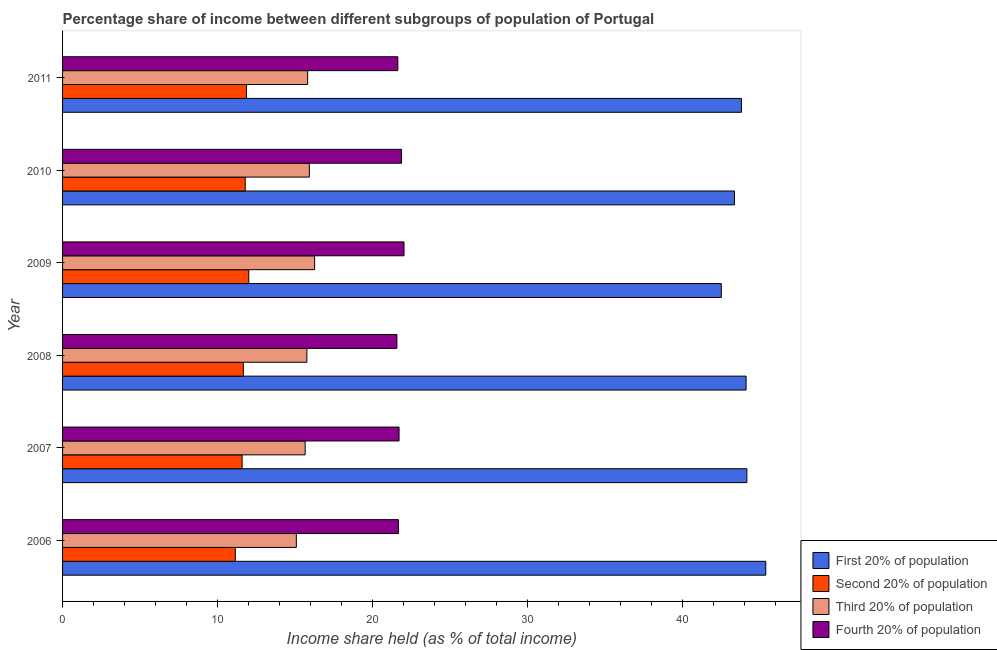How many different coloured bars are there?
Ensure brevity in your answer.  4. How many groups of bars are there?
Your answer should be very brief. 6. Are the number of bars on each tick of the Y-axis equal?
Provide a succinct answer. Yes. In how many cases, is the number of bars for a given year not equal to the number of legend labels?
Give a very brief answer. 0. What is the share of the income held by second 20% of the population in 2011?
Make the answer very short. 11.87. Across all years, what is the maximum share of the income held by second 20% of the population?
Your answer should be very brief. 12.02. Across all years, what is the minimum share of the income held by first 20% of the population?
Offer a terse response. 42.52. In which year was the share of the income held by second 20% of the population minimum?
Provide a succinct answer. 2006. What is the total share of the income held by first 20% of the population in the graph?
Your response must be concise. 263.39. What is the difference between the share of the income held by second 20% of the population in 2009 and that in 2010?
Your response must be concise. 0.23. What is the difference between the share of the income held by second 20% of the population in 2009 and the share of the income held by first 20% of the population in 2007?
Offer a terse response. -32.15. What is the average share of the income held by first 20% of the population per year?
Your answer should be compact. 43.9. In the year 2006, what is the difference between the share of the income held by fourth 20% of the population and share of the income held by third 20% of the population?
Provide a succinct answer. 6.59. In how many years, is the share of the income held by first 20% of the population greater than 2 %?
Offer a terse response. 6. What is the ratio of the share of the income held by first 20% of the population in 2007 to that in 2009?
Offer a terse response. 1.04. Is the share of the income held by second 20% of the population in 2009 less than that in 2011?
Your answer should be compact. No. What is the difference between the highest and the second highest share of the income held by second 20% of the population?
Ensure brevity in your answer.  0.15. What is the difference between the highest and the lowest share of the income held by third 20% of the population?
Give a very brief answer. 1.18. In how many years, is the share of the income held by first 20% of the population greater than the average share of the income held by first 20% of the population taken over all years?
Your answer should be compact. 3. Is the sum of the share of the income held by first 20% of the population in 2006 and 2010 greater than the maximum share of the income held by second 20% of the population across all years?
Offer a terse response. Yes. Is it the case that in every year, the sum of the share of the income held by third 20% of the population and share of the income held by fourth 20% of the population is greater than the sum of share of the income held by first 20% of the population and share of the income held by second 20% of the population?
Ensure brevity in your answer.  No. What does the 2nd bar from the top in 2006 represents?
Provide a short and direct response. Third 20% of population. What does the 1st bar from the bottom in 2008 represents?
Provide a short and direct response. First 20% of population. How many bars are there?
Your answer should be compact. 24. How many years are there in the graph?
Provide a short and direct response. 6. Does the graph contain any zero values?
Provide a succinct answer. No. Where does the legend appear in the graph?
Offer a terse response. Bottom right. How many legend labels are there?
Ensure brevity in your answer.  4. How are the legend labels stacked?
Offer a terse response. Vertical. What is the title of the graph?
Ensure brevity in your answer.  Percentage share of income between different subgroups of population of Portugal. What is the label or title of the X-axis?
Ensure brevity in your answer.  Income share held (as % of total income). What is the Income share held (as % of total income) in First 20% of population in 2006?
Your answer should be compact. 45.39. What is the Income share held (as % of total income) in Second 20% of population in 2006?
Keep it short and to the point. 11.15. What is the Income share held (as % of total income) in Third 20% of population in 2006?
Offer a terse response. 15.09. What is the Income share held (as % of total income) in Fourth 20% of population in 2006?
Provide a succinct answer. 21.68. What is the Income share held (as % of total income) in First 20% of population in 2007?
Ensure brevity in your answer.  44.17. What is the Income share held (as % of total income) of Second 20% of population in 2007?
Provide a succinct answer. 11.59. What is the Income share held (as % of total income) in Third 20% of population in 2007?
Provide a short and direct response. 15.66. What is the Income share held (as % of total income) in Fourth 20% of population in 2007?
Your answer should be compact. 21.72. What is the Income share held (as % of total income) in First 20% of population in 2008?
Make the answer very short. 44.12. What is the Income share held (as % of total income) in Second 20% of population in 2008?
Offer a very short reply. 11.67. What is the Income share held (as % of total income) of Third 20% of population in 2008?
Offer a terse response. 15.77. What is the Income share held (as % of total income) of Fourth 20% of population in 2008?
Your response must be concise. 21.58. What is the Income share held (as % of total income) in First 20% of population in 2009?
Your answer should be compact. 42.52. What is the Income share held (as % of total income) in Second 20% of population in 2009?
Offer a terse response. 12.02. What is the Income share held (as % of total income) in Third 20% of population in 2009?
Keep it short and to the point. 16.27. What is the Income share held (as % of total income) of Fourth 20% of population in 2009?
Keep it short and to the point. 22.04. What is the Income share held (as % of total income) in First 20% of population in 2010?
Offer a very short reply. 43.37. What is the Income share held (as % of total income) of Second 20% of population in 2010?
Provide a succinct answer. 11.79. What is the Income share held (as % of total income) of Third 20% of population in 2010?
Your response must be concise. 15.93. What is the Income share held (as % of total income) of Fourth 20% of population in 2010?
Give a very brief answer. 21.88. What is the Income share held (as % of total income) of First 20% of population in 2011?
Provide a short and direct response. 43.82. What is the Income share held (as % of total income) of Second 20% of population in 2011?
Make the answer very short. 11.87. What is the Income share held (as % of total income) in Third 20% of population in 2011?
Offer a terse response. 15.82. What is the Income share held (as % of total income) of Fourth 20% of population in 2011?
Your response must be concise. 21.64. Across all years, what is the maximum Income share held (as % of total income) of First 20% of population?
Offer a very short reply. 45.39. Across all years, what is the maximum Income share held (as % of total income) in Second 20% of population?
Offer a terse response. 12.02. Across all years, what is the maximum Income share held (as % of total income) of Third 20% of population?
Offer a terse response. 16.27. Across all years, what is the maximum Income share held (as % of total income) of Fourth 20% of population?
Ensure brevity in your answer.  22.04. Across all years, what is the minimum Income share held (as % of total income) in First 20% of population?
Keep it short and to the point. 42.52. Across all years, what is the minimum Income share held (as % of total income) in Second 20% of population?
Keep it short and to the point. 11.15. Across all years, what is the minimum Income share held (as % of total income) of Third 20% of population?
Offer a very short reply. 15.09. Across all years, what is the minimum Income share held (as % of total income) of Fourth 20% of population?
Ensure brevity in your answer.  21.58. What is the total Income share held (as % of total income) in First 20% of population in the graph?
Your answer should be compact. 263.39. What is the total Income share held (as % of total income) of Second 20% of population in the graph?
Keep it short and to the point. 70.09. What is the total Income share held (as % of total income) in Third 20% of population in the graph?
Offer a terse response. 94.54. What is the total Income share held (as % of total income) in Fourth 20% of population in the graph?
Your response must be concise. 130.54. What is the difference between the Income share held (as % of total income) in First 20% of population in 2006 and that in 2007?
Your response must be concise. 1.22. What is the difference between the Income share held (as % of total income) in Second 20% of population in 2006 and that in 2007?
Offer a very short reply. -0.44. What is the difference between the Income share held (as % of total income) of Third 20% of population in 2006 and that in 2007?
Keep it short and to the point. -0.57. What is the difference between the Income share held (as % of total income) of Fourth 20% of population in 2006 and that in 2007?
Provide a short and direct response. -0.04. What is the difference between the Income share held (as % of total income) of First 20% of population in 2006 and that in 2008?
Your response must be concise. 1.27. What is the difference between the Income share held (as % of total income) of Second 20% of population in 2006 and that in 2008?
Make the answer very short. -0.52. What is the difference between the Income share held (as % of total income) in Third 20% of population in 2006 and that in 2008?
Provide a short and direct response. -0.68. What is the difference between the Income share held (as % of total income) in Fourth 20% of population in 2006 and that in 2008?
Give a very brief answer. 0.1. What is the difference between the Income share held (as % of total income) of First 20% of population in 2006 and that in 2009?
Offer a terse response. 2.87. What is the difference between the Income share held (as % of total income) in Second 20% of population in 2006 and that in 2009?
Provide a short and direct response. -0.87. What is the difference between the Income share held (as % of total income) of Third 20% of population in 2006 and that in 2009?
Your answer should be compact. -1.18. What is the difference between the Income share held (as % of total income) of Fourth 20% of population in 2006 and that in 2009?
Your response must be concise. -0.36. What is the difference between the Income share held (as % of total income) of First 20% of population in 2006 and that in 2010?
Provide a succinct answer. 2.02. What is the difference between the Income share held (as % of total income) of Second 20% of population in 2006 and that in 2010?
Your answer should be very brief. -0.64. What is the difference between the Income share held (as % of total income) in Third 20% of population in 2006 and that in 2010?
Provide a short and direct response. -0.84. What is the difference between the Income share held (as % of total income) in First 20% of population in 2006 and that in 2011?
Make the answer very short. 1.57. What is the difference between the Income share held (as % of total income) in Second 20% of population in 2006 and that in 2011?
Your answer should be compact. -0.72. What is the difference between the Income share held (as % of total income) in Third 20% of population in 2006 and that in 2011?
Your answer should be very brief. -0.73. What is the difference between the Income share held (as % of total income) of Fourth 20% of population in 2006 and that in 2011?
Keep it short and to the point. 0.04. What is the difference between the Income share held (as % of total income) of First 20% of population in 2007 and that in 2008?
Ensure brevity in your answer.  0.05. What is the difference between the Income share held (as % of total income) of Second 20% of population in 2007 and that in 2008?
Provide a short and direct response. -0.08. What is the difference between the Income share held (as % of total income) in Third 20% of population in 2007 and that in 2008?
Your answer should be very brief. -0.11. What is the difference between the Income share held (as % of total income) of Fourth 20% of population in 2007 and that in 2008?
Provide a short and direct response. 0.14. What is the difference between the Income share held (as % of total income) of First 20% of population in 2007 and that in 2009?
Your answer should be compact. 1.65. What is the difference between the Income share held (as % of total income) of Second 20% of population in 2007 and that in 2009?
Give a very brief answer. -0.43. What is the difference between the Income share held (as % of total income) in Third 20% of population in 2007 and that in 2009?
Make the answer very short. -0.61. What is the difference between the Income share held (as % of total income) in Fourth 20% of population in 2007 and that in 2009?
Ensure brevity in your answer.  -0.32. What is the difference between the Income share held (as % of total income) in First 20% of population in 2007 and that in 2010?
Your answer should be very brief. 0.8. What is the difference between the Income share held (as % of total income) of Third 20% of population in 2007 and that in 2010?
Offer a terse response. -0.27. What is the difference between the Income share held (as % of total income) in Fourth 20% of population in 2007 and that in 2010?
Ensure brevity in your answer.  -0.16. What is the difference between the Income share held (as % of total income) in Second 20% of population in 2007 and that in 2011?
Make the answer very short. -0.28. What is the difference between the Income share held (as % of total income) in Third 20% of population in 2007 and that in 2011?
Keep it short and to the point. -0.16. What is the difference between the Income share held (as % of total income) in First 20% of population in 2008 and that in 2009?
Your answer should be compact. 1.6. What is the difference between the Income share held (as % of total income) of Second 20% of population in 2008 and that in 2009?
Give a very brief answer. -0.35. What is the difference between the Income share held (as % of total income) of Fourth 20% of population in 2008 and that in 2009?
Make the answer very short. -0.46. What is the difference between the Income share held (as % of total income) of Second 20% of population in 2008 and that in 2010?
Your answer should be compact. -0.12. What is the difference between the Income share held (as % of total income) of Third 20% of population in 2008 and that in 2010?
Provide a short and direct response. -0.16. What is the difference between the Income share held (as % of total income) in Fourth 20% of population in 2008 and that in 2010?
Your answer should be compact. -0.3. What is the difference between the Income share held (as % of total income) in Second 20% of population in 2008 and that in 2011?
Offer a very short reply. -0.2. What is the difference between the Income share held (as % of total income) of Third 20% of population in 2008 and that in 2011?
Your answer should be compact. -0.05. What is the difference between the Income share held (as % of total income) in Fourth 20% of population in 2008 and that in 2011?
Your answer should be very brief. -0.06. What is the difference between the Income share held (as % of total income) in First 20% of population in 2009 and that in 2010?
Offer a very short reply. -0.85. What is the difference between the Income share held (as % of total income) in Second 20% of population in 2009 and that in 2010?
Give a very brief answer. 0.23. What is the difference between the Income share held (as % of total income) of Third 20% of population in 2009 and that in 2010?
Keep it short and to the point. 0.34. What is the difference between the Income share held (as % of total income) in Fourth 20% of population in 2009 and that in 2010?
Provide a short and direct response. 0.16. What is the difference between the Income share held (as % of total income) of Third 20% of population in 2009 and that in 2011?
Your answer should be very brief. 0.45. What is the difference between the Income share held (as % of total income) of Fourth 20% of population in 2009 and that in 2011?
Your response must be concise. 0.4. What is the difference between the Income share held (as % of total income) in First 20% of population in 2010 and that in 2011?
Your answer should be very brief. -0.45. What is the difference between the Income share held (as % of total income) in Second 20% of population in 2010 and that in 2011?
Offer a terse response. -0.08. What is the difference between the Income share held (as % of total income) in Third 20% of population in 2010 and that in 2011?
Offer a very short reply. 0.11. What is the difference between the Income share held (as % of total income) of Fourth 20% of population in 2010 and that in 2011?
Your answer should be very brief. 0.24. What is the difference between the Income share held (as % of total income) of First 20% of population in 2006 and the Income share held (as % of total income) of Second 20% of population in 2007?
Make the answer very short. 33.8. What is the difference between the Income share held (as % of total income) of First 20% of population in 2006 and the Income share held (as % of total income) of Third 20% of population in 2007?
Give a very brief answer. 29.73. What is the difference between the Income share held (as % of total income) in First 20% of population in 2006 and the Income share held (as % of total income) in Fourth 20% of population in 2007?
Keep it short and to the point. 23.67. What is the difference between the Income share held (as % of total income) in Second 20% of population in 2006 and the Income share held (as % of total income) in Third 20% of population in 2007?
Keep it short and to the point. -4.51. What is the difference between the Income share held (as % of total income) in Second 20% of population in 2006 and the Income share held (as % of total income) in Fourth 20% of population in 2007?
Provide a succinct answer. -10.57. What is the difference between the Income share held (as % of total income) of Third 20% of population in 2006 and the Income share held (as % of total income) of Fourth 20% of population in 2007?
Your response must be concise. -6.63. What is the difference between the Income share held (as % of total income) of First 20% of population in 2006 and the Income share held (as % of total income) of Second 20% of population in 2008?
Provide a short and direct response. 33.72. What is the difference between the Income share held (as % of total income) of First 20% of population in 2006 and the Income share held (as % of total income) of Third 20% of population in 2008?
Your answer should be very brief. 29.62. What is the difference between the Income share held (as % of total income) of First 20% of population in 2006 and the Income share held (as % of total income) of Fourth 20% of population in 2008?
Keep it short and to the point. 23.81. What is the difference between the Income share held (as % of total income) of Second 20% of population in 2006 and the Income share held (as % of total income) of Third 20% of population in 2008?
Provide a succinct answer. -4.62. What is the difference between the Income share held (as % of total income) of Second 20% of population in 2006 and the Income share held (as % of total income) of Fourth 20% of population in 2008?
Provide a short and direct response. -10.43. What is the difference between the Income share held (as % of total income) in Third 20% of population in 2006 and the Income share held (as % of total income) in Fourth 20% of population in 2008?
Ensure brevity in your answer.  -6.49. What is the difference between the Income share held (as % of total income) of First 20% of population in 2006 and the Income share held (as % of total income) of Second 20% of population in 2009?
Ensure brevity in your answer.  33.37. What is the difference between the Income share held (as % of total income) in First 20% of population in 2006 and the Income share held (as % of total income) in Third 20% of population in 2009?
Ensure brevity in your answer.  29.12. What is the difference between the Income share held (as % of total income) in First 20% of population in 2006 and the Income share held (as % of total income) in Fourth 20% of population in 2009?
Offer a very short reply. 23.35. What is the difference between the Income share held (as % of total income) in Second 20% of population in 2006 and the Income share held (as % of total income) in Third 20% of population in 2009?
Give a very brief answer. -5.12. What is the difference between the Income share held (as % of total income) of Second 20% of population in 2006 and the Income share held (as % of total income) of Fourth 20% of population in 2009?
Offer a very short reply. -10.89. What is the difference between the Income share held (as % of total income) of Third 20% of population in 2006 and the Income share held (as % of total income) of Fourth 20% of population in 2009?
Provide a succinct answer. -6.95. What is the difference between the Income share held (as % of total income) in First 20% of population in 2006 and the Income share held (as % of total income) in Second 20% of population in 2010?
Make the answer very short. 33.6. What is the difference between the Income share held (as % of total income) in First 20% of population in 2006 and the Income share held (as % of total income) in Third 20% of population in 2010?
Make the answer very short. 29.46. What is the difference between the Income share held (as % of total income) of First 20% of population in 2006 and the Income share held (as % of total income) of Fourth 20% of population in 2010?
Give a very brief answer. 23.51. What is the difference between the Income share held (as % of total income) of Second 20% of population in 2006 and the Income share held (as % of total income) of Third 20% of population in 2010?
Provide a short and direct response. -4.78. What is the difference between the Income share held (as % of total income) in Second 20% of population in 2006 and the Income share held (as % of total income) in Fourth 20% of population in 2010?
Offer a very short reply. -10.73. What is the difference between the Income share held (as % of total income) in Third 20% of population in 2006 and the Income share held (as % of total income) in Fourth 20% of population in 2010?
Your answer should be compact. -6.79. What is the difference between the Income share held (as % of total income) in First 20% of population in 2006 and the Income share held (as % of total income) in Second 20% of population in 2011?
Give a very brief answer. 33.52. What is the difference between the Income share held (as % of total income) of First 20% of population in 2006 and the Income share held (as % of total income) of Third 20% of population in 2011?
Provide a succinct answer. 29.57. What is the difference between the Income share held (as % of total income) in First 20% of population in 2006 and the Income share held (as % of total income) in Fourth 20% of population in 2011?
Provide a succinct answer. 23.75. What is the difference between the Income share held (as % of total income) in Second 20% of population in 2006 and the Income share held (as % of total income) in Third 20% of population in 2011?
Your response must be concise. -4.67. What is the difference between the Income share held (as % of total income) in Second 20% of population in 2006 and the Income share held (as % of total income) in Fourth 20% of population in 2011?
Give a very brief answer. -10.49. What is the difference between the Income share held (as % of total income) of Third 20% of population in 2006 and the Income share held (as % of total income) of Fourth 20% of population in 2011?
Give a very brief answer. -6.55. What is the difference between the Income share held (as % of total income) in First 20% of population in 2007 and the Income share held (as % of total income) in Second 20% of population in 2008?
Ensure brevity in your answer.  32.5. What is the difference between the Income share held (as % of total income) in First 20% of population in 2007 and the Income share held (as % of total income) in Third 20% of population in 2008?
Offer a very short reply. 28.4. What is the difference between the Income share held (as % of total income) of First 20% of population in 2007 and the Income share held (as % of total income) of Fourth 20% of population in 2008?
Your answer should be compact. 22.59. What is the difference between the Income share held (as % of total income) of Second 20% of population in 2007 and the Income share held (as % of total income) of Third 20% of population in 2008?
Ensure brevity in your answer.  -4.18. What is the difference between the Income share held (as % of total income) in Second 20% of population in 2007 and the Income share held (as % of total income) in Fourth 20% of population in 2008?
Make the answer very short. -9.99. What is the difference between the Income share held (as % of total income) of Third 20% of population in 2007 and the Income share held (as % of total income) of Fourth 20% of population in 2008?
Your response must be concise. -5.92. What is the difference between the Income share held (as % of total income) in First 20% of population in 2007 and the Income share held (as % of total income) in Second 20% of population in 2009?
Ensure brevity in your answer.  32.15. What is the difference between the Income share held (as % of total income) in First 20% of population in 2007 and the Income share held (as % of total income) in Third 20% of population in 2009?
Offer a terse response. 27.9. What is the difference between the Income share held (as % of total income) of First 20% of population in 2007 and the Income share held (as % of total income) of Fourth 20% of population in 2009?
Give a very brief answer. 22.13. What is the difference between the Income share held (as % of total income) of Second 20% of population in 2007 and the Income share held (as % of total income) of Third 20% of population in 2009?
Offer a very short reply. -4.68. What is the difference between the Income share held (as % of total income) of Second 20% of population in 2007 and the Income share held (as % of total income) of Fourth 20% of population in 2009?
Offer a terse response. -10.45. What is the difference between the Income share held (as % of total income) of Third 20% of population in 2007 and the Income share held (as % of total income) of Fourth 20% of population in 2009?
Offer a very short reply. -6.38. What is the difference between the Income share held (as % of total income) in First 20% of population in 2007 and the Income share held (as % of total income) in Second 20% of population in 2010?
Your answer should be very brief. 32.38. What is the difference between the Income share held (as % of total income) of First 20% of population in 2007 and the Income share held (as % of total income) of Third 20% of population in 2010?
Your answer should be compact. 28.24. What is the difference between the Income share held (as % of total income) in First 20% of population in 2007 and the Income share held (as % of total income) in Fourth 20% of population in 2010?
Provide a short and direct response. 22.29. What is the difference between the Income share held (as % of total income) in Second 20% of population in 2007 and the Income share held (as % of total income) in Third 20% of population in 2010?
Offer a terse response. -4.34. What is the difference between the Income share held (as % of total income) of Second 20% of population in 2007 and the Income share held (as % of total income) of Fourth 20% of population in 2010?
Offer a terse response. -10.29. What is the difference between the Income share held (as % of total income) in Third 20% of population in 2007 and the Income share held (as % of total income) in Fourth 20% of population in 2010?
Give a very brief answer. -6.22. What is the difference between the Income share held (as % of total income) of First 20% of population in 2007 and the Income share held (as % of total income) of Second 20% of population in 2011?
Your answer should be very brief. 32.3. What is the difference between the Income share held (as % of total income) in First 20% of population in 2007 and the Income share held (as % of total income) in Third 20% of population in 2011?
Offer a terse response. 28.35. What is the difference between the Income share held (as % of total income) in First 20% of population in 2007 and the Income share held (as % of total income) in Fourth 20% of population in 2011?
Your answer should be very brief. 22.53. What is the difference between the Income share held (as % of total income) in Second 20% of population in 2007 and the Income share held (as % of total income) in Third 20% of population in 2011?
Ensure brevity in your answer.  -4.23. What is the difference between the Income share held (as % of total income) of Second 20% of population in 2007 and the Income share held (as % of total income) of Fourth 20% of population in 2011?
Your answer should be very brief. -10.05. What is the difference between the Income share held (as % of total income) of Third 20% of population in 2007 and the Income share held (as % of total income) of Fourth 20% of population in 2011?
Offer a terse response. -5.98. What is the difference between the Income share held (as % of total income) of First 20% of population in 2008 and the Income share held (as % of total income) of Second 20% of population in 2009?
Your response must be concise. 32.1. What is the difference between the Income share held (as % of total income) of First 20% of population in 2008 and the Income share held (as % of total income) of Third 20% of population in 2009?
Give a very brief answer. 27.85. What is the difference between the Income share held (as % of total income) of First 20% of population in 2008 and the Income share held (as % of total income) of Fourth 20% of population in 2009?
Make the answer very short. 22.08. What is the difference between the Income share held (as % of total income) of Second 20% of population in 2008 and the Income share held (as % of total income) of Fourth 20% of population in 2009?
Your answer should be very brief. -10.37. What is the difference between the Income share held (as % of total income) of Third 20% of population in 2008 and the Income share held (as % of total income) of Fourth 20% of population in 2009?
Give a very brief answer. -6.27. What is the difference between the Income share held (as % of total income) of First 20% of population in 2008 and the Income share held (as % of total income) of Second 20% of population in 2010?
Offer a terse response. 32.33. What is the difference between the Income share held (as % of total income) of First 20% of population in 2008 and the Income share held (as % of total income) of Third 20% of population in 2010?
Offer a very short reply. 28.19. What is the difference between the Income share held (as % of total income) in First 20% of population in 2008 and the Income share held (as % of total income) in Fourth 20% of population in 2010?
Provide a succinct answer. 22.24. What is the difference between the Income share held (as % of total income) of Second 20% of population in 2008 and the Income share held (as % of total income) of Third 20% of population in 2010?
Offer a terse response. -4.26. What is the difference between the Income share held (as % of total income) in Second 20% of population in 2008 and the Income share held (as % of total income) in Fourth 20% of population in 2010?
Provide a succinct answer. -10.21. What is the difference between the Income share held (as % of total income) in Third 20% of population in 2008 and the Income share held (as % of total income) in Fourth 20% of population in 2010?
Ensure brevity in your answer.  -6.11. What is the difference between the Income share held (as % of total income) of First 20% of population in 2008 and the Income share held (as % of total income) of Second 20% of population in 2011?
Provide a short and direct response. 32.25. What is the difference between the Income share held (as % of total income) in First 20% of population in 2008 and the Income share held (as % of total income) in Third 20% of population in 2011?
Your response must be concise. 28.3. What is the difference between the Income share held (as % of total income) in First 20% of population in 2008 and the Income share held (as % of total income) in Fourth 20% of population in 2011?
Give a very brief answer. 22.48. What is the difference between the Income share held (as % of total income) in Second 20% of population in 2008 and the Income share held (as % of total income) in Third 20% of population in 2011?
Your answer should be compact. -4.15. What is the difference between the Income share held (as % of total income) of Second 20% of population in 2008 and the Income share held (as % of total income) of Fourth 20% of population in 2011?
Your response must be concise. -9.97. What is the difference between the Income share held (as % of total income) of Third 20% of population in 2008 and the Income share held (as % of total income) of Fourth 20% of population in 2011?
Ensure brevity in your answer.  -5.87. What is the difference between the Income share held (as % of total income) in First 20% of population in 2009 and the Income share held (as % of total income) in Second 20% of population in 2010?
Your answer should be compact. 30.73. What is the difference between the Income share held (as % of total income) in First 20% of population in 2009 and the Income share held (as % of total income) in Third 20% of population in 2010?
Keep it short and to the point. 26.59. What is the difference between the Income share held (as % of total income) of First 20% of population in 2009 and the Income share held (as % of total income) of Fourth 20% of population in 2010?
Make the answer very short. 20.64. What is the difference between the Income share held (as % of total income) of Second 20% of population in 2009 and the Income share held (as % of total income) of Third 20% of population in 2010?
Provide a short and direct response. -3.91. What is the difference between the Income share held (as % of total income) of Second 20% of population in 2009 and the Income share held (as % of total income) of Fourth 20% of population in 2010?
Offer a terse response. -9.86. What is the difference between the Income share held (as % of total income) in Third 20% of population in 2009 and the Income share held (as % of total income) in Fourth 20% of population in 2010?
Keep it short and to the point. -5.61. What is the difference between the Income share held (as % of total income) of First 20% of population in 2009 and the Income share held (as % of total income) of Second 20% of population in 2011?
Your answer should be compact. 30.65. What is the difference between the Income share held (as % of total income) in First 20% of population in 2009 and the Income share held (as % of total income) in Third 20% of population in 2011?
Make the answer very short. 26.7. What is the difference between the Income share held (as % of total income) in First 20% of population in 2009 and the Income share held (as % of total income) in Fourth 20% of population in 2011?
Make the answer very short. 20.88. What is the difference between the Income share held (as % of total income) of Second 20% of population in 2009 and the Income share held (as % of total income) of Fourth 20% of population in 2011?
Keep it short and to the point. -9.62. What is the difference between the Income share held (as % of total income) in Third 20% of population in 2009 and the Income share held (as % of total income) in Fourth 20% of population in 2011?
Provide a short and direct response. -5.37. What is the difference between the Income share held (as % of total income) of First 20% of population in 2010 and the Income share held (as % of total income) of Second 20% of population in 2011?
Offer a terse response. 31.5. What is the difference between the Income share held (as % of total income) in First 20% of population in 2010 and the Income share held (as % of total income) in Third 20% of population in 2011?
Provide a succinct answer. 27.55. What is the difference between the Income share held (as % of total income) in First 20% of population in 2010 and the Income share held (as % of total income) in Fourth 20% of population in 2011?
Offer a terse response. 21.73. What is the difference between the Income share held (as % of total income) in Second 20% of population in 2010 and the Income share held (as % of total income) in Third 20% of population in 2011?
Keep it short and to the point. -4.03. What is the difference between the Income share held (as % of total income) in Second 20% of population in 2010 and the Income share held (as % of total income) in Fourth 20% of population in 2011?
Your response must be concise. -9.85. What is the difference between the Income share held (as % of total income) of Third 20% of population in 2010 and the Income share held (as % of total income) of Fourth 20% of population in 2011?
Your answer should be compact. -5.71. What is the average Income share held (as % of total income) of First 20% of population per year?
Your answer should be compact. 43.9. What is the average Income share held (as % of total income) of Second 20% of population per year?
Your answer should be very brief. 11.68. What is the average Income share held (as % of total income) of Third 20% of population per year?
Provide a short and direct response. 15.76. What is the average Income share held (as % of total income) of Fourth 20% of population per year?
Give a very brief answer. 21.76. In the year 2006, what is the difference between the Income share held (as % of total income) of First 20% of population and Income share held (as % of total income) of Second 20% of population?
Your answer should be very brief. 34.24. In the year 2006, what is the difference between the Income share held (as % of total income) of First 20% of population and Income share held (as % of total income) of Third 20% of population?
Ensure brevity in your answer.  30.3. In the year 2006, what is the difference between the Income share held (as % of total income) of First 20% of population and Income share held (as % of total income) of Fourth 20% of population?
Give a very brief answer. 23.71. In the year 2006, what is the difference between the Income share held (as % of total income) in Second 20% of population and Income share held (as % of total income) in Third 20% of population?
Your answer should be very brief. -3.94. In the year 2006, what is the difference between the Income share held (as % of total income) in Second 20% of population and Income share held (as % of total income) in Fourth 20% of population?
Offer a terse response. -10.53. In the year 2006, what is the difference between the Income share held (as % of total income) in Third 20% of population and Income share held (as % of total income) in Fourth 20% of population?
Make the answer very short. -6.59. In the year 2007, what is the difference between the Income share held (as % of total income) in First 20% of population and Income share held (as % of total income) in Second 20% of population?
Ensure brevity in your answer.  32.58. In the year 2007, what is the difference between the Income share held (as % of total income) of First 20% of population and Income share held (as % of total income) of Third 20% of population?
Provide a short and direct response. 28.51. In the year 2007, what is the difference between the Income share held (as % of total income) of First 20% of population and Income share held (as % of total income) of Fourth 20% of population?
Give a very brief answer. 22.45. In the year 2007, what is the difference between the Income share held (as % of total income) of Second 20% of population and Income share held (as % of total income) of Third 20% of population?
Make the answer very short. -4.07. In the year 2007, what is the difference between the Income share held (as % of total income) of Second 20% of population and Income share held (as % of total income) of Fourth 20% of population?
Your answer should be compact. -10.13. In the year 2007, what is the difference between the Income share held (as % of total income) of Third 20% of population and Income share held (as % of total income) of Fourth 20% of population?
Your response must be concise. -6.06. In the year 2008, what is the difference between the Income share held (as % of total income) of First 20% of population and Income share held (as % of total income) of Second 20% of population?
Keep it short and to the point. 32.45. In the year 2008, what is the difference between the Income share held (as % of total income) in First 20% of population and Income share held (as % of total income) in Third 20% of population?
Provide a succinct answer. 28.35. In the year 2008, what is the difference between the Income share held (as % of total income) in First 20% of population and Income share held (as % of total income) in Fourth 20% of population?
Your answer should be very brief. 22.54. In the year 2008, what is the difference between the Income share held (as % of total income) of Second 20% of population and Income share held (as % of total income) of Third 20% of population?
Ensure brevity in your answer.  -4.1. In the year 2008, what is the difference between the Income share held (as % of total income) in Second 20% of population and Income share held (as % of total income) in Fourth 20% of population?
Offer a terse response. -9.91. In the year 2008, what is the difference between the Income share held (as % of total income) of Third 20% of population and Income share held (as % of total income) of Fourth 20% of population?
Provide a succinct answer. -5.81. In the year 2009, what is the difference between the Income share held (as % of total income) in First 20% of population and Income share held (as % of total income) in Second 20% of population?
Your answer should be compact. 30.5. In the year 2009, what is the difference between the Income share held (as % of total income) in First 20% of population and Income share held (as % of total income) in Third 20% of population?
Your response must be concise. 26.25. In the year 2009, what is the difference between the Income share held (as % of total income) of First 20% of population and Income share held (as % of total income) of Fourth 20% of population?
Provide a short and direct response. 20.48. In the year 2009, what is the difference between the Income share held (as % of total income) of Second 20% of population and Income share held (as % of total income) of Third 20% of population?
Ensure brevity in your answer.  -4.25. In the year 2009, what is the difference between the Income share held (as % of total income) in Second 20% of population and Income share held (as % of total income) in Fourth 20% of population?
Make the answer very short. -10.02. In the year 2009, what is the difference between the Income share held (as % of total income) in Third 20% of population and Income share held (as % of total income) in Fourth 20% of population?
Offer a terse response. -5.77. In the year 2010, what is the difference between the Income share held (as % of total income) in First 20% of population and Income share held (as % of total income) in Second 20% of population?
Offer a terse response. 31.58. In the year 2010, what is the difference between the Income share held (as % of total income) of First 20% of population and Income share held (as % of total income) of Third 20% of population?
Offer a terse response. 27.44. In the year 2010, what is the difference between the Income share held (as % of total income) in First 20% of population and Income share held (as % of total income) in Fourth 20% of population?
Offer a terse response. 21.49. In the year 2010, what is the difference between the Income share held (as % of total income) of Second 20% of population and Income share held (as % of total income) of Third 20% of population?
Offer a very short reply. -4.14. In the year 2010, what is the difference between the Income share held (as % of total income) of Second 20% of population and Income share held (as % of total income) of Fourth 20% of population?
Offer a terse response. -10.09. In the year 2010, what is the difference between the Income share held (as % of total income) of Third 20% of population and Income share held (as % of total income) of Fourth 20% of population?
Provide a succinct answer. -5.95. In the year 2011, what is the difference between the Income share held (as % of total income) of First 20% of population and Income share held (as % of total income) of Second 20% of population?
Your answer should be compact. 31.95. In the year 2011, what is the difference between the Income share held (as % of total income) in First 20% of population and Income share held (as % of total income) in Fourth 20% of population?
Your answer should be compact. 22.18. In the year 2011, what is the difference between the Income share held (as % of total income) in Second 20% of population and Income share held (as % of total income) in Third 20% of population?
Provide a short and direct response. -3.95. In the year 2011, what is the difference between the Income share held (as % of total income) in Second 20% of population and Income share held (as % of total income) in Fourth 20% of population?
Your response must be concise. -9.77. In the year 2011, what is the difference between the Income share held (as % of total income) in Third 20% of population and Income share held (as % of total income) in Fourth 20% of population?
Keep it short and to the point. -5.82. What is the ratio of the Income share held (as % of total income) in First 20% of population in 2006 to that in 2007?
Your answer should be very brief. 1.03. What is the ratio of the Income share held (as % of total income) in Second 20% of population in 2006 to that in 2007?
Provide a succinct answer. 0.96. What is the ratio of the Income share held (as % of total income) in Third 20% of population in 2006 to that in 2007?
Give a very brief answer. 0.96. What is the ratio of the Income share held (as % of total income) in Fourth 20% of population in 2006 to that in 2007?
Make the answer very short. 1. What is the ratio of the Income share held (as % of total income) of First 20% of population in 2006 to that in 2008?
Provide a short and direct response. 1.03. What is the ratio of the Income share held (as % of total income) in Second 20% of population in 2006 to that in 2008?
Offer a terse response. 0.96. What is the ratio of the Income share held (as % of total income) in Third 20% of population in 2006 to that in 2008?
Make the answer very short. 0.96. What is the ratio of the Income share held (as % of total income) of First 20% of population in 2006 to that in 2009?
Give a very brief answer. 1.07. What is the ratio of the Income share held (as % of total income) in Second 20% of population in 2006 to that in 2009?
Give a very brief answer. 0.93. What is the ratio of the Income share held (as % of total income) in Third 20% of population in 2006 to that in 2009?
Ensure brevity in your answer.  0.93. What is the ratio of the Income share held (as % of total income) in Fourth 20% of population in 2006 to that in 2009?
Offer a terse response. 0.98. What is the ratio of the Income share held (as % of total income) of First 20% of population in 2006 to that in 2010?
Give a very brief answer. 1.05. What is the ratio of the Income share held (as % of total income) in Second 20% of population in 2006 to that in 2010?
Your answer should be compact. 0.95. What is the ratio of the Income share held (as % of total income) in Third 20% of population in 2006 to that in 2010?
Offer a very short reply. 0.95. What is the ratio of the Income share held (as % of total income) in Fourth 20% of population in 2006 to that in 2010?
Give a very brief answer. 0.99. What is the ratio of the Income share held (as % of total income) of First 20% of population in 2006 to that in 2011?
Provide a short and direct response. 1.04. What is the ratio of the Income share held (as % of total income) of Second 20% of population in 2006 to that in 2011?
Keep it short and to the point. 0.94. What is the ratio of the Income share held (as % of total income) of Third 20% of population in 2006 to that in 2011?
Provide a succinct answer. 0.95. What is the ratio of the Income share held (as % of total income) in Second 20% of population in 2007 to that in 2008?
Offer a very short reply. 0.99. What is the ratio of the Income share held (as % of total income) of First 20% of population in 2007 to that in 2009?
Make the answer very short. 1.04. What is the ratio of the Income share held (as % of total income) in Second 20% of population in 2007 to that in 2009?
Keep it short and to the point. 0.96. What is the ratio of the Income share held (as % of total income) of Third 20% of population in 2007 to that in 2009?
Offer a very short reply. 0.96. What is the ratio of the Income share held (as % of total income) in Fourth 20% of population in 2007 to that in 2009?
Keep it short and to the point. 0.99. What is the ratio of the Income share held (as % of total income) of First 20% of population in 2007 to that in 2010?
Your answer should be compact. 1.02. What is the ratio of the Income share held (as % of total income) of Third 20% of population in 2007 to that in 2010?
Ensure brevity in your answer.  0.98. What is the ratio of the Income share held (as % of total income) of Fourth 20% of population in 2007 to that in 2010?
Your response must be concise. 0.99. What is the ratio of the Income share held (as % of total income) in First 20% of population in 2007 to that in 2011?
Offer a very short reply. 1.01. What is the ratio of the Income share held (as % of total income) in Second 20% of population in 2007 to that in 2011?
Ensure brevity in your answer.  0.98. What is the ratio of the Income share held (as % of total income) in Fourth 20% of population in 2007 to that in 2011?
Provide a short and direct response. 1. What is the ratio of the Income share held (as % of total income) of First 20% of population in 2008 to that in 2009?
Give a very brief answer. 1.04. What is the ratio of the Income share held (as % of total income) of Second 20% of population in 2008 to that in 2009?
Keep it short and to the point. 0.97. What is the ratio of the Income share held (as % of total income) in Third 20% of population in 2008 to that in 2009?
Offer a terse response. 0.97. What is the ratio of the Income share held (as % of total income) of Fourth 20% of population in 2008 to that in 2009?
Your answer should be compact. 0.98. What is the ratio of the Income share held (as % of total income) in First 20% of population in 2008 to that in 2010?
Your response must be concise. 1.02. What is the ratio of the Income share held (as % of total income) in Fourth 20% of population in 2008 to that in 2010?
Provide a succinct answer. 0.99. What is the ratio of the Income share held (as % of total income) in First 20% of population in 2008 to that in 2011?
Provide a short and direct response. 1.01. What is the ratio of the Income share held (as % of total income) of Second 20% of population in 2008 to that in 2011?
Offer a very short reply. 0.98. What is the ratio of the Income share held (as % of total income) in Third 20% of population in 2008 to that in 2011?
Ensure brevity in your answer.  1. What is the ratio of the Income share held (as % of total income) in Fourth 20% of population in 2008 to that in 2011?
Offer a very short reply. 1. What is the ratio of the Income share held (as % of total income) in First 20% of population in 2009 to that in 2010?
Provide a succinct answer. 0.98. What is the ratio of the Income share held (as % of total income) of Second 20% of population in 2009 to that in 2010?
Provide a short and direct response. 1.02. What is the ratio of the Income share held (as % of total income) in Third 20% of population in 2009 to that in 2010?
Provide a succinct answer. 1.02. What is the ratio of the Income share held (as % of total income) of Fourth 20% of population in 2009 to that in 2010?
Your response must be concise. 1.01. What is the ratio of the Income share held (as % of total income) in First 20% of population in 2009 to that in 2011?
Ensure brevity in your answer.  0.97. What is the ratio of the Income share held (as % of total income) of Second 20% of population in 2009 to that in 2011?
Make the answer very short. 1.01. What is the ratio of the Income share held (as % of total income) in Third 20% of population in 2009 to that in 2011?
Make the answer very short. 1.03. What is the ratio of the Income share held (as % of total income) in Fourth 20% of population in 2009 to that in 2011?
Provide a short and direct response. 1.02. What is the ratio of the Income share held (as % of total income) of Third 20% of population in 2010 to that in 2011?
Make the answer very short. 1.01. What is the ratio of the Income share held (as % of total income) of Fourth 20% of population in 2010 to that in 2011?
Provide a short and direct response. 1.01. What is the difference between the highest and the second highest Income share held (as % of total income) in First 20% of population?
Ensure brevity in your answer.  1.22. What is the difference between the highest and the second highest Income share held (as % of total income) in Second 20% of population?
Provide a succinct answer. 0.15. What is the difference between the highest and the second highest Income share held (as % of total income) in Third 20% of population?
Your response must be concise. 0.34. What is the difference between the highest and the second highest Income share held (as % of total income) of Fourth 20% of population?
Make the answer very short. 0.16. What is the difference between the highest and the lowest Income share held (as % of total income) in First 20% of population?
Keep it short and to the point. 2.87. What is the difference between the highest and the lowest Income share held (as % of total income) of Second 20% of population?
Your response must be concise. 0.87. What is the difference between the highest and the lowest Income share held (as % of total income) of Third 20% of population?
Give a very brief answer. 1.18. What is the difference between the highest and the lowest Income share held (as % of total income) in Fourth 20% of population?
Provide a short and direct response. 0.46. 